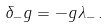Convert formula to latex. <formula><loc_0><loc_0><loc_500><loc_500>\delta _ { - } g = - g \lambda _ { - } \, .</formula> 